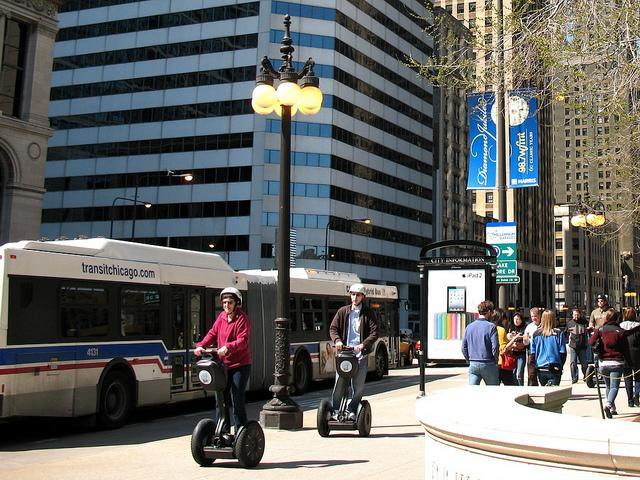Why are the the two riders wearing helmets?

Choices:
A) identification
B) protect heads
C) fashion
D) incognito protect heads 